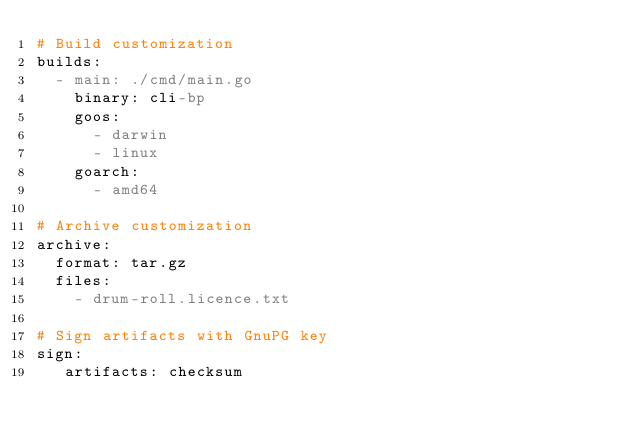Convert code to text. <code><loc_0><loc_0><loc_500><loc_500><_YAML_># Build customization
builds:
  - main: ./cmd/main.go
    binary: cli-bp
    goos:
      - darwin
      - linux
    goarch:
      - amd64

# Archive customization
archive:
  format: tar.gz
  files:
    - drum-roll.licence.txt

# Sign artifacts with GnuPG key
sign:
   artifacts: checksum
</code> 